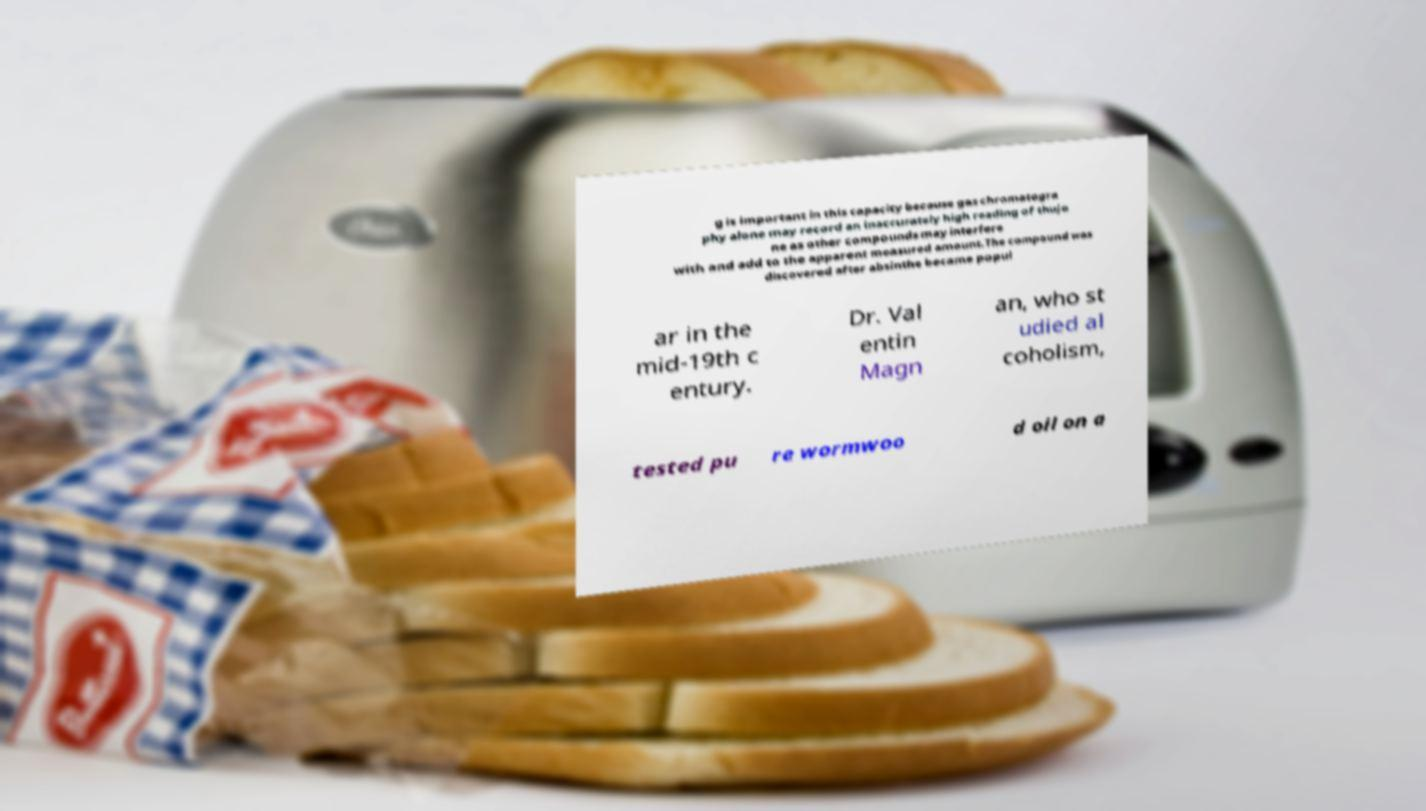For documentation purposes, I need the text within this image transcribed. Could you provide that? g is important in this capacity because gas chromatogra phy alone may record an inaccurately high reading of thujo ne as other compounds may interfere with and add to the apparent measured amount.The compound was discovered after absinthe became popul ar in the mid-19th c entury. Dr. Val entin Magn an, who st udied al coholism, tested pu re wormwoo d oil on a 